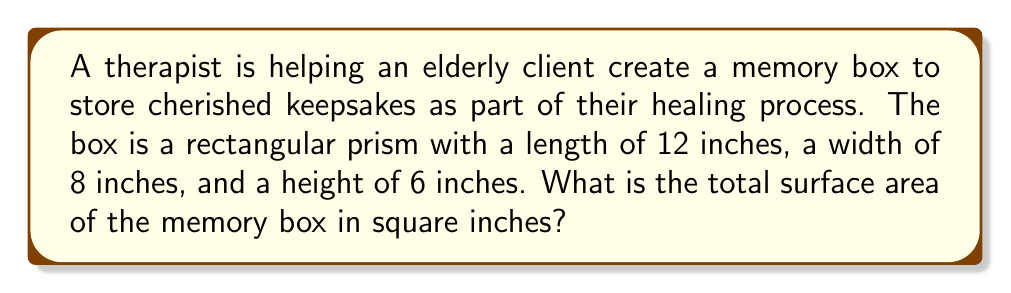Could you help me with this problem? Let's approach this step-by-step:

1) The memory box is a rectangular prism. The surface area of a rectangular prism is the sum of the areas of all six faces.

2) For a rectangular prism, there are three pairs of identical faces:
   - Two rectangular faces with length and width (top and bottom)
   - Two rectangular faces with length and height (front and back)
   - Two rectangular faces with width and height (left and right sides)

3) Let's calculate the area of each pair:
   - Top and bottom: $A_1 = 2 * (l * w) = 2 * (12 * 8) = 2 * 96 = 192$ sq inches
   - Front and back: $A_2 = 2 * (l * h) = 2 * (12 * 6) = 2 * 72 = 144$ sq inches
   - Left and right: $A_3 = 2 * (w * h) = 2 * (8 * 6) = 2 * 48 = 96$ sq inches

4) The total surface area is the sum of all these areas:

   $$SA = A_1 + A_2 + A_3 = 192 + 144 + 96 = 432$$ sq inches

Therefore, the total surface area of the memory box is 432 square inches.
Answer: 432 sq in 